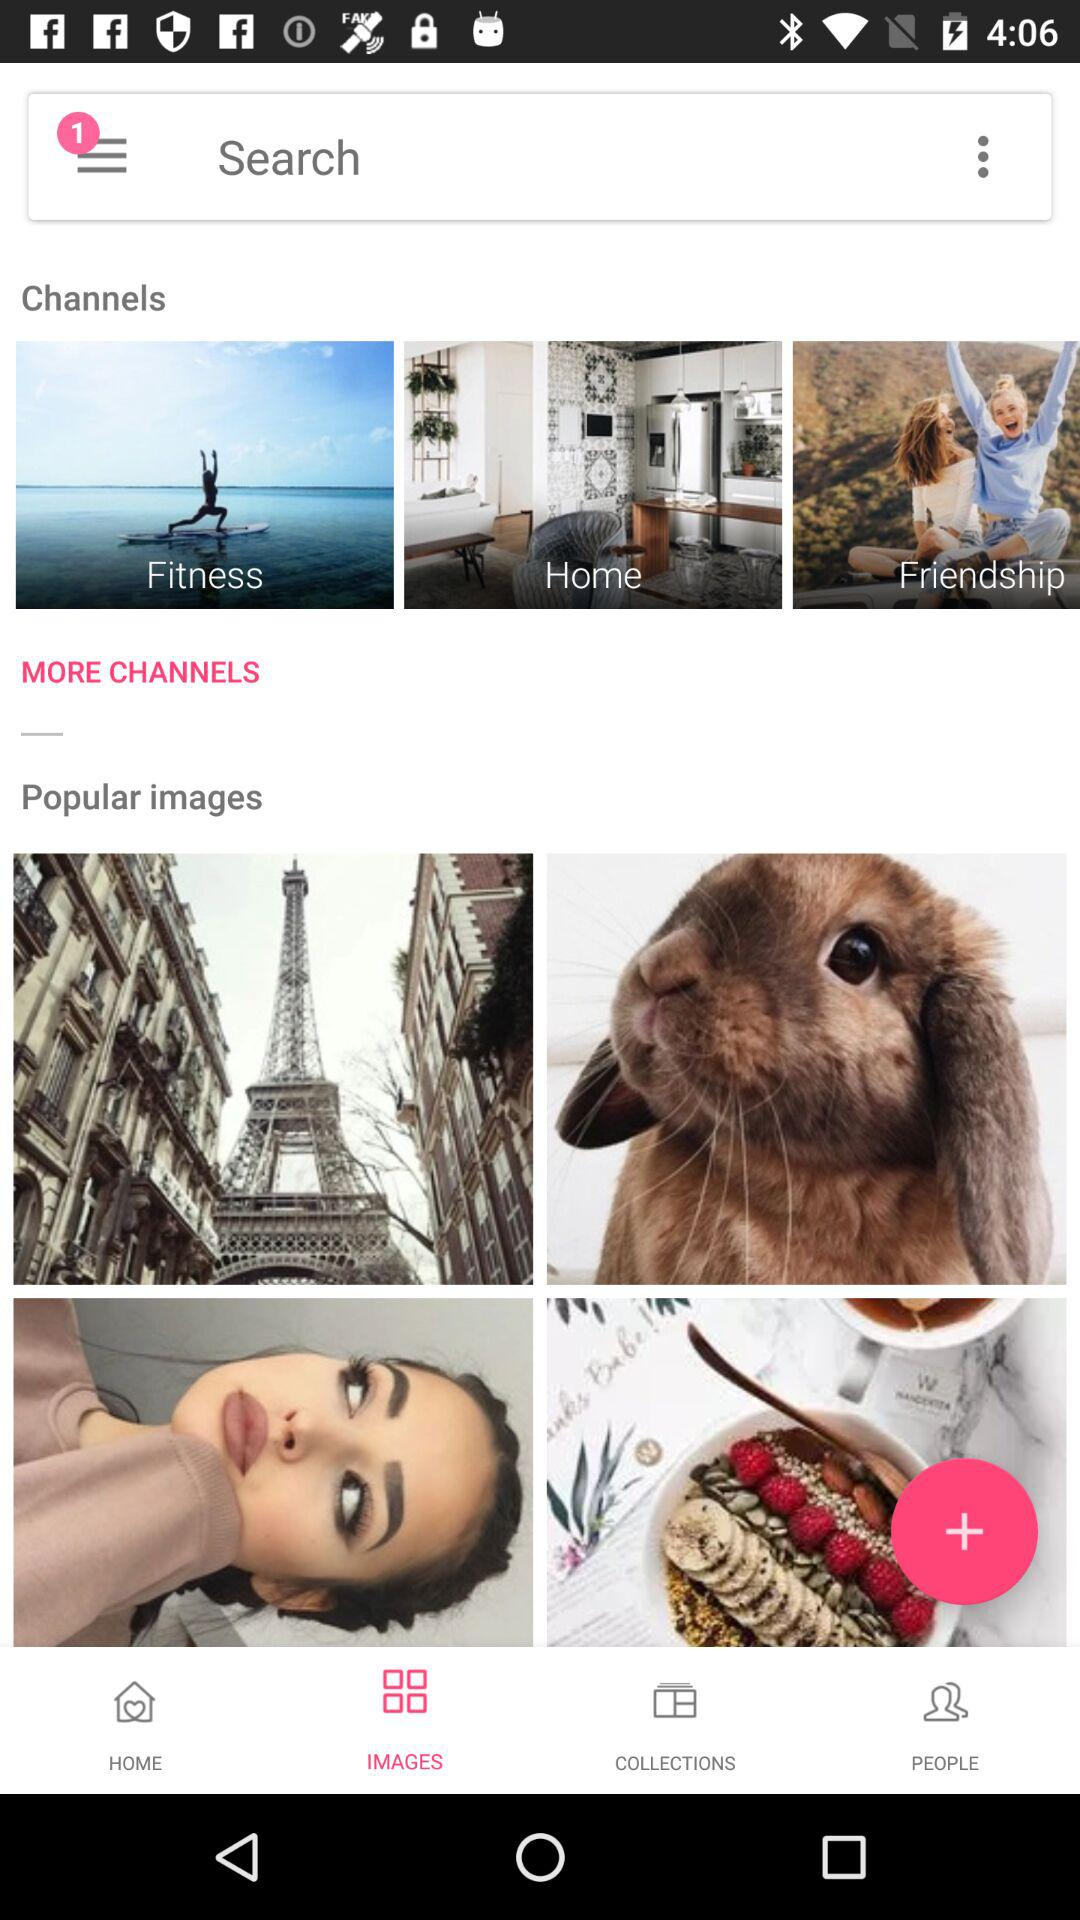Which tab is selected in the taskbar? The selected tab is "IMAGES". 